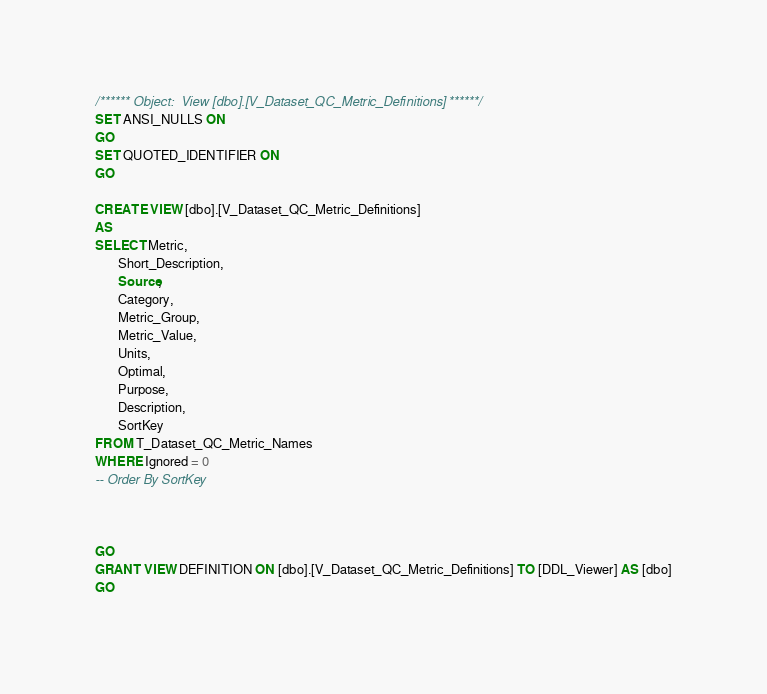Convert code to text. <code><loc_0><loc_0><loc_500><loc_500><_SQL_>/****** Object:  View [dbo].[V_Dataset_QC_Metric_Definitions] ******/
SET ANSI_NULLS ON
GO
SET QUOTED_IDENTIFIER ON
GO

CREATE VIEW [dbo].[V_Dataset_QC_Metric_Definitions]
AS 
SELECT Metric,
       Short_Description,
	   Source,
       Category,
       Metric_Group,
       Metric_Value,
       Units,
       Optimal,
       Purpose,
       Description,       
       SortKey
FROM T_Dataset_QC_Metric_Names
WHERE Ignored = 0
-- Order By SortKey



GO
GRANT VIEW DEFINITION ON [dbo].[V_Dataset_QC_Metric_Definitions] TO [DDL_Viewer] AS [dbo]
GO
</code> 